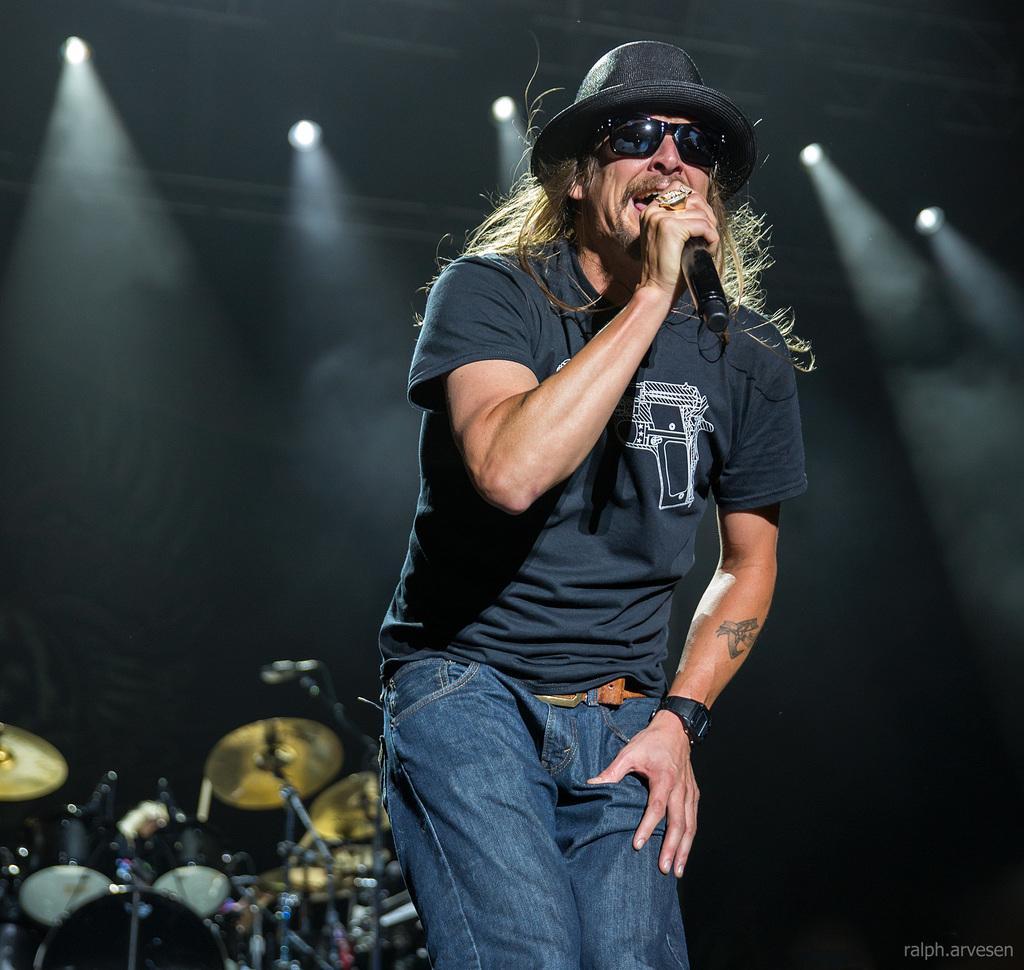Please provide a concise description of this image. An old man wearing a navy blue t-shirt and black hat and jeans with watch on his left hand,singing on a mic. There is drum kit in the behind and the light focusing from the ceiling. 